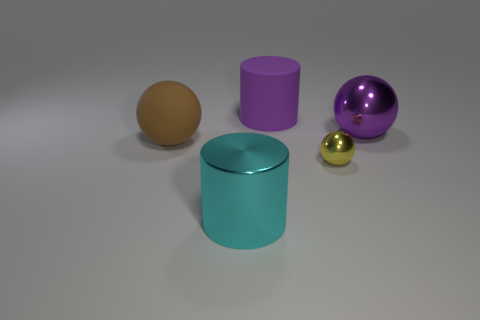Add 2 big brown matte cubes. How many objects exist? 7 Subtract all cylinders. How many objects are left? 3 Subtract 0 green cylinders. How many objects are left? 5 Subtract all large green blocks. Subtract all large brown matte balls. How many objects are left? 4 Add 2 big purple objects. How many big purple objects are left? 4 Add 1 big purple rubber cylinders. How many big purple rubber cylinders exist? 2 